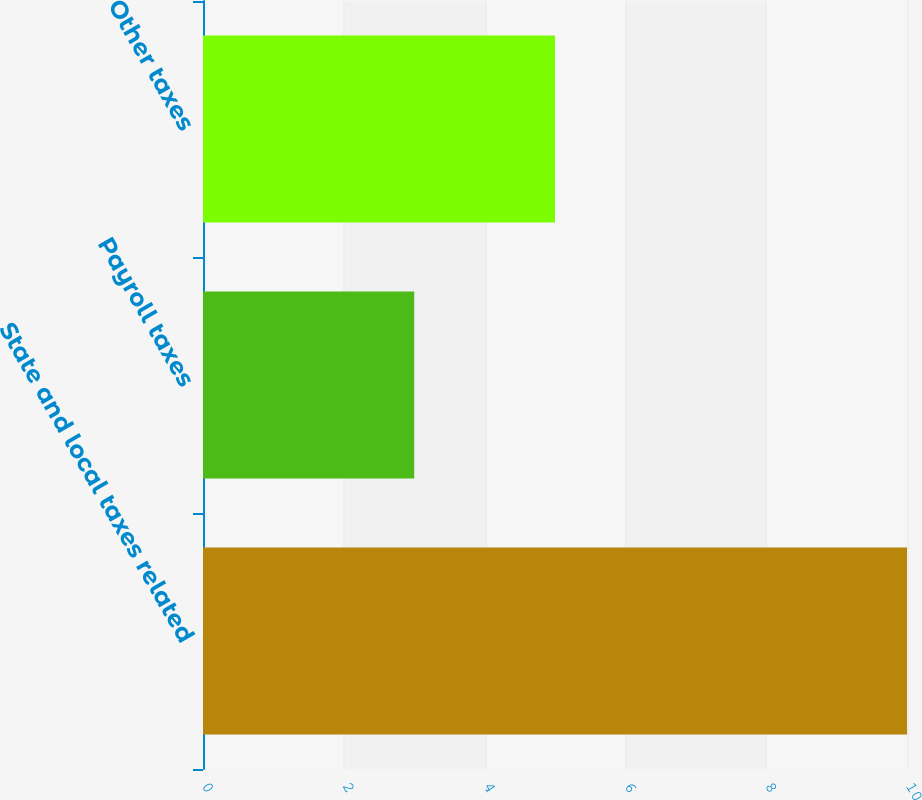Convert chart to OTSL. <chart><loc_0><loc_0><loc_500><loc_500><bar_chart><fcel>State and local taxes related<fcel>Payroll taxes<fcel>Other taxes<nl><fcel>10<fcel>3<fcel>5<nl></chart> 